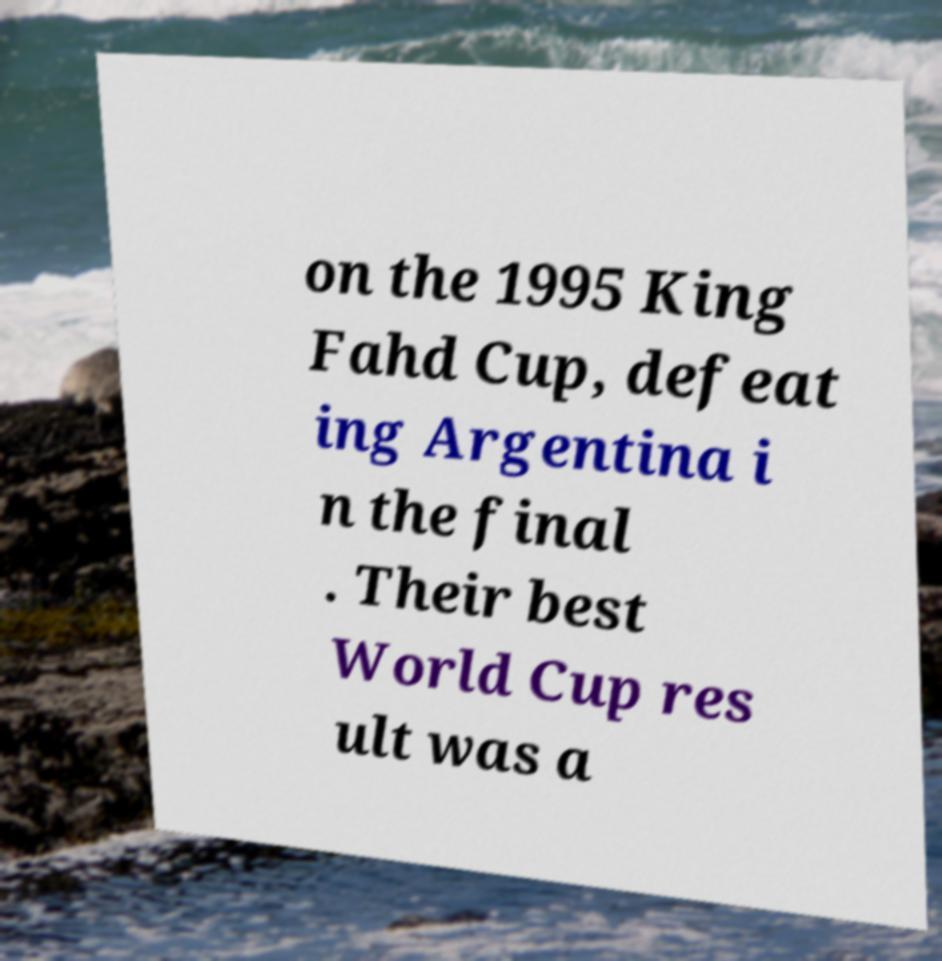Can you read and provide the text displayed in the image?This photo seems to have some interesting text. Can you extract and type it out for me? on the 1995 King Fahd Cup, defeat ing Argentina i n the final . Their best World Cup res ult was a 